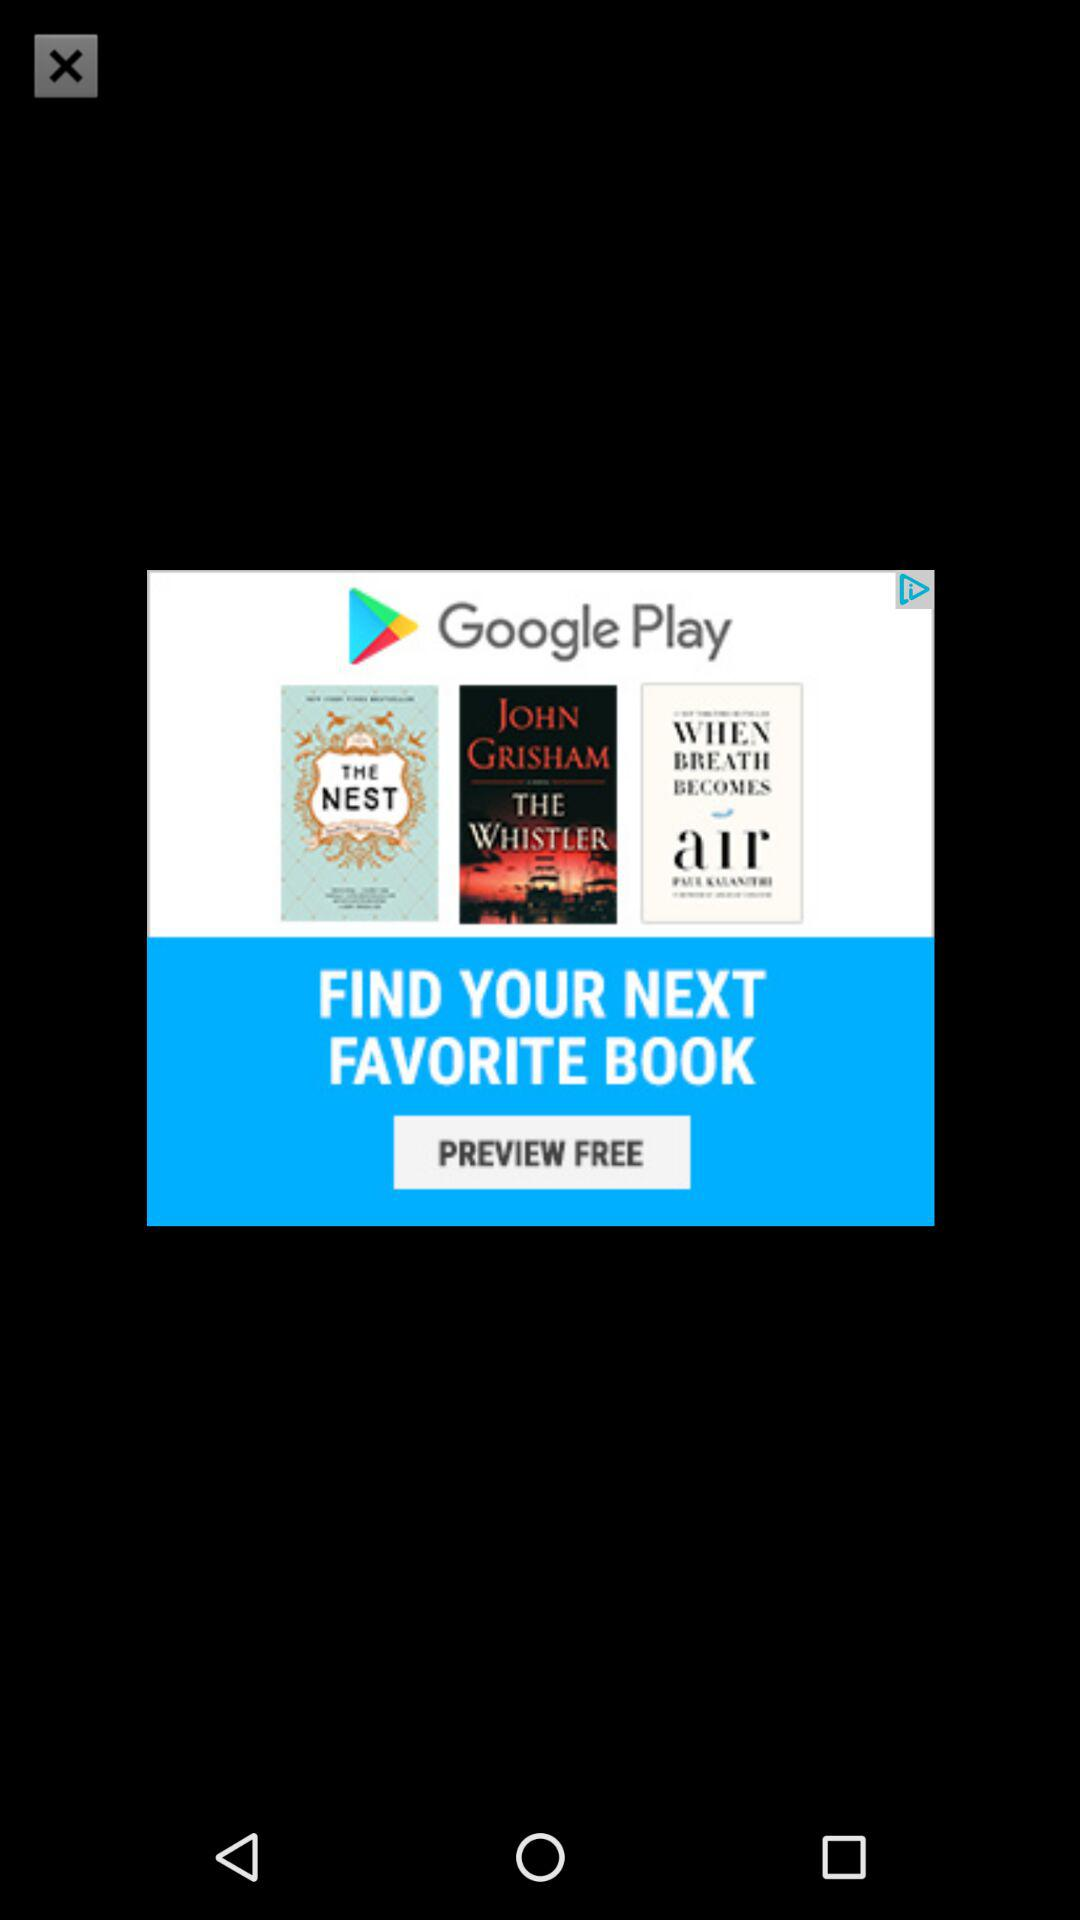How many books are being advertised?
Answer the question using a single word or phrase. 3 